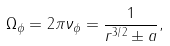<formula> <loc_0><loc_0><loc_500><loc_500>\Omega _ { \phi } = 2 \pi \nu _ { \phi } = \frac { 1 } { r ^ { 3 / 2 } \pm a } ,</formula> 